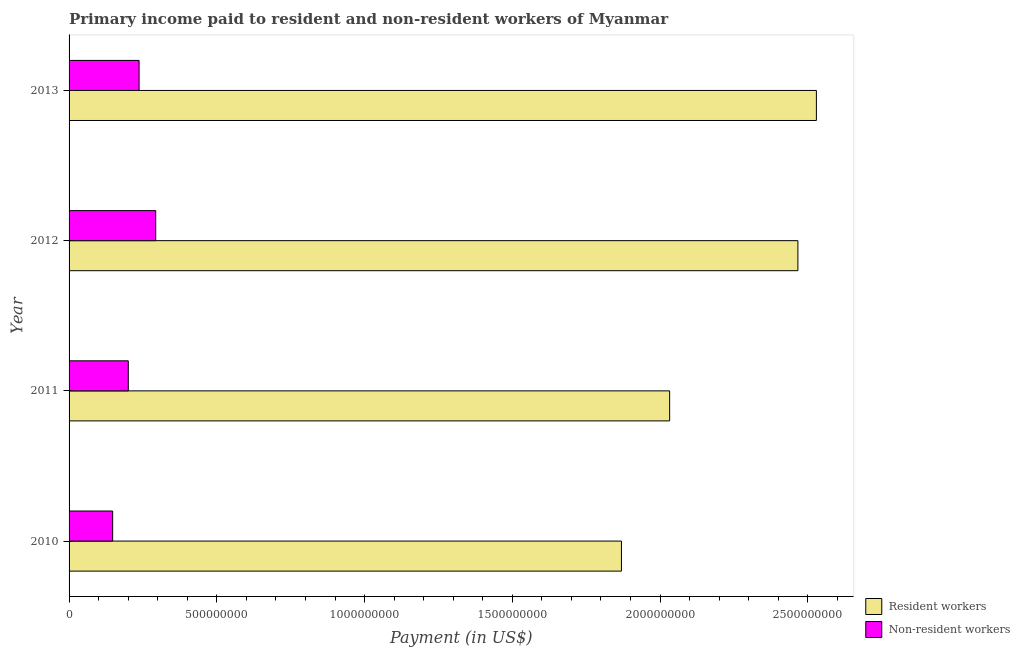Are the number of bars on each tick of the Y-axis equal?
Your answer should be very brief. Yes. What is the label of the 2nd group of bars from the top?
Ensure brevity in your answer.  2012. In how many cases, is the number of bars for a given year not equal to the number of legend labels?
Your answer should be compact. 0. What is the payment made to non-resident workers in 2013?
Provide a succinct answer. 2.37e+08. Across all years, what is the maximum payment made to resident workers?
Your response must be concise. 2.53e+09. Across all years, what is the minimum payment made to resident workers?
Your answer should be compact. 1.87e+09. In which year was the payment made to resident workers minimum?
Provide a short and direct response. 2010. What is the total payment made to non-resident workers in the graph?
Offer a very short reply. 8.78e+08. What is the difference between the payment made to resident workers in 2010 and that in 2011?
Provide a succinct answer. -1.63e+08. What is the difference between the payment made to resident workers in 2010 and the payment made to non-resident workers in 2012?
Ensure brevity in your answer.  1.58e+09. What is the average payment made to resident workers per year?
Offer a terse response. 2.22e+09. In the year 2012, what is the difference between the payment made to non-resident workers and payment made to resident workers?
Your answer should be very brief. -2.17e+09. What is the ratio of the payment made to non-resident workers in 2011 to that in 2012?
Keep it short and to the point. 0.68. Is the payment made to resident workers in 2011 less than that in 2013?
Your response must be concise. Yes. What is the difference between the highest and the second highest payment made to non-resident workers?
Your response must be concise. 5.63e+07. What is the difference between the highest and the lowest payment made to resident workers?
Keep it short and to the point. 6.60e+08. Is the sum of the payment made to non-resident workers in 2010 and 2013 greater than the maximum payment made to resident workers across all years?
Offer a very short reply. No. What does the 2nd bar from the top in 2011 represents?
Offer a terse response. Resident workers. What does the 1st bar from the bottom in 2011 represents?
Your answer should be very brief. Resident workers. How many years are there in the graph?
Keep it short and to the point. 4. What is the difference between two consecutive major ticks on the X-axis?
Offer a very short reply. 5.00e+08. Are the values on the major ticks of X-axis written in scientific E-notation?
Make the answer very short. No. Does the graph contain any zero values?
Offer a very short reply. No. How many legend labels are there?
Keep it short and to the point. 2. How are the legend labels stacked?
Make the answer very short. Vertical. What is the title of the graph?
Your answer should be very brief. Primary income paid to resident and non-resident workers of Myanmar. What is the label or title of the X-axis?
Your answer should be very brief. Payment (in US$). What is the label or title of the Y-axis?
Give a very brief answer. Year. What is the Payment (in US$) in Resident workers in 2010?
Your answer should be compact. 1.87e+09. What is the Payment (in US$) in Non-resident workers in 2010?
Keep it short and to the point. 1.48e+08. What is the Payment (in US$) in Resident workers in 2011?
Your answer should be very brief. 2.03e+09. What is the Payment (in US$) in Non-resident workers in 2011?
Offer a very short reply. 2.00e+08. What is the Payment (in US$) in Resident workers in 2012?
Make the answer very short. 2.47e+09. What is the Payment (in US$) of Non-resident workers in 2012?
Keep it short and to the point. 2.93e+08. What is the Payment (in US$) in Resident workers in 2013?
Keep it short and to the point. 2.53e+09. What is the Payment (in US$) in Non-resident workers in 2013?
Provide a succinct answer. 2.37e+08. Across all years, what is the maximum Payment (in US$) of Resident workers?
Offer a very short reply. 2.53e+09. Across all years, what is the maximum Payment (in US$) of Non-resident workers?
Offer a terse response. 2.93e+08. Across all years, what is the minimum Payment (in US$) of Resident workers?
Offer a very short reply. 1.87e+09. Across all years, what is the minimum Payment (in US$) in Non-resident workers?
Ensure brevity in your answer.  1.48e+08. What is the total Payment (in US$) in Resident workers in the graph?
Give a very brief answer. 8.90e+09. What is the total Payment (in US$) of Non-resident workers in the graph?
Provide a short and direct response. 8.78e+08. What is the difference between the Payment (in US$) in Resident workers in 2010 and that in 2011?
Make the answer very short. -1.63e+08. What is the difference between the Payment (in US$) in Non-resident workers in 2010 and that in 2011?
Keep it short and to the point. -5.29e+07. What is the difference between the Payment (in US$) of Resident workers in 2010 and that in 2012?
Offer a very short reply. -5.97e+08. What is the difference between the Payment (in US$) in Non-resident workers in 2010 and that in 2012?
Provide a succinct answer. -1.46e+08. What is the difference between the Payment (in US$) in Resident workers in 2010 and that in 2013?
Your answer should be compact. -6.60e+08. What is the difference between the Payment (in US$) of Non-resident workers in 2010 and that in 2013?
Offer a terse response. -8.94e+07. What is the difference between the Payment (in US$) in Resident workers in 2011 and that in 2012?
Make the answer very short. -4.34e+08. What is the difference between the Payment (in US$) in Non-resident workers in 2011 and that in 2012?
Your answer should be very brief. -9.28e+07. What is the difference between the Payment (in US$) in Resident workers in 2011 and that in 2013?
Your response must be concise. -4.97e+08. What is the difference between the Payment (in US$) in Non-resident workers in 2011 and that in 2013?
Your answer should be compact. -3.65e+07. What is the difference between the Payment (in US$) in Resident workers in 2012 and that in 2013?
Provide a short and direct response. -6.26e+07. What is the difference between the Payment (in US$) in Non-resident workers in 2012 and that in 2013?
Give a very brief answer. 5.63e+07. What is the difference between the Payment (in US$) in Resident workers in 2010 and the Payment (in US$) in Non-resident workers in 2011?
Provide a succinct answer. 1.67e+09. What is the difference between the Payment (in US$) of Resident workers in 2010 and the Payment (in US$) of Non-resident workers in 2012?
Keep it short and to the point. 1.58e+09. What is the difference between the Payment (in US$) in Resident workers in 2010 and the Payment (in US$) in Non-resident workers in 2013?
Keep it short and to the point. 1.63e+09. What is the difference between the Payment (in US$) in Resident workers in 2011 and the Payment (in US$) in Non-resident workers in 2012?
Give a very brief answer. 1.74e+09. What is the difference between the Payment (in US$) of Resident workers in 2011 and the Payment (in US$) of Non-resident workers in 2013?
Your answer should be very brief. 1.80e+09. What is the difference between the Payment (in US$) in Resident workers in 2012 and the Payment (in US$) in Non-resident workers in 2013?
Provide a short and direct response. 2.23e+09. What is the average Payment (in US$) in Resident workers per year?
Keep it short and to the point. 2.22e+09. What is the average Payment (in US$) of Non-resident workers per year?
Your answer should be very brief. 2.20e+08. In the year 2010, what is the difference between the Payment (in US$) in Resident workers and Payment (in US$) in Non-resident workers?
Offer a very short reply. 1.72e+09. In the year 2011, what is the difference between the Payment (in US$) in Resident workers and Payment (in US$) in Non-resident workers?
Offer a terse response. 1.83e+09. In the year 2012, what is the difference between the Payment (in US$) of Resident workers and Payment (in US$) of Non-resident workers?
Give a very brief answer. 2.17e+09. In the year 2013, what is the difference between the Payment (in US$) in Resident workers and Payment (in US$) in Non-resident workers?
Offer a very short reply. 2.29e+09. What is the ratio of the Payment (in US$) in Resident workers in 2010 to that in 2011?
Your response must be concise. 0.92. What is the ratio of the Payment (in US$) in Non-resident workers in 2010 to that in 2011?
Offer a very short reply. 0.74. What is the ratio of the Payment (in US$) in Resident workers in 2010 to that in 2012?
Your answer should be very brief. 0.76. What is the ratio of the Payment (in US$) of Non-resident workers in 2010 to that in 2012?
Your answer should be very brief. 0.5. What is the ratio of the Payment (in US$) of Resident workers in 2010 to that in 2013?
Provide a succinct answer. 0.74. What is the ratio of the Payment (in US$) of Non-resident workers in 2010 to that in 2013?
Make the answer very short. 0.62. What is the ratio of the Payment (in US$) of Resident workers in 2011 to that in 2012?
Give a very brief answer. 0.82. What is the ratio of the Payment (in US$) of Non-resident workers in 2011 to that in 2012?
Offer a terse response. 0.68. What is the ratio of the Payment (in US$) in Resident workers in 2011 to that in 2013?
Your response must be concise. 0.8. What is the ratio of the Payment (in US$) of Non-resident workers in 2011 to that in 2013?
Keep it short and to the point. 0.85. What is the ratio of the Payment (in US$) of Resident workers in 2012 to that in 2013?
Your answer should be compact. 0.98. What is the ratio of the Payment (in US$) in Non-resident workers in 2012 to that in 2013?
Provide a succinct answer. 1.24. What is the difference between the highest and the second highest Payment (in US$) of Resident workers?
Your answer should be very brief. 6.26e+07. What is the difference between the highest and the second highest Payment (in US$) of Non-resident workers?
Offer a very short reply. 5.63e+07. What is the difference between the highest and the lowest Payment (in US$) in Resident workers?
Give a very brief answer. 6.60e+08. What is the difference between the highest and the lowest Payment (in US$) of Non-resident workers?
Give a very brief answer. 1.46e+08. 